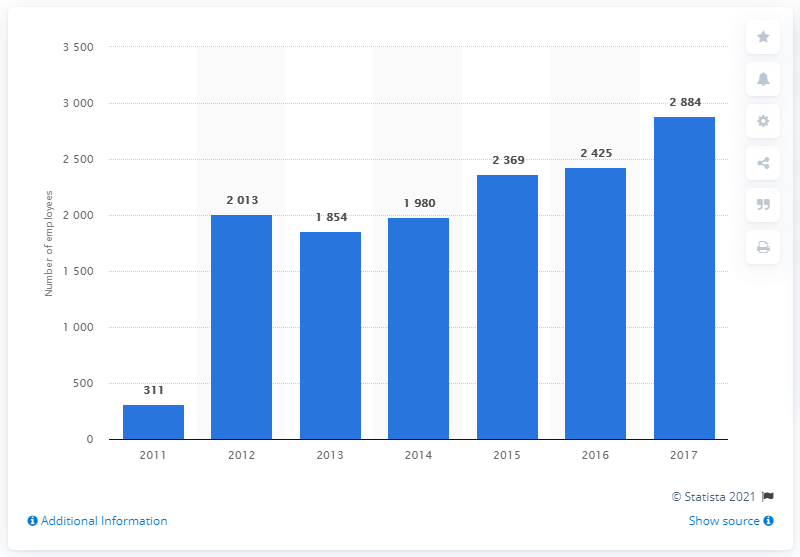Draw attention to some important aspects in this diagram. In 2017, Dolce & Gabbana employed 2,884 people. 